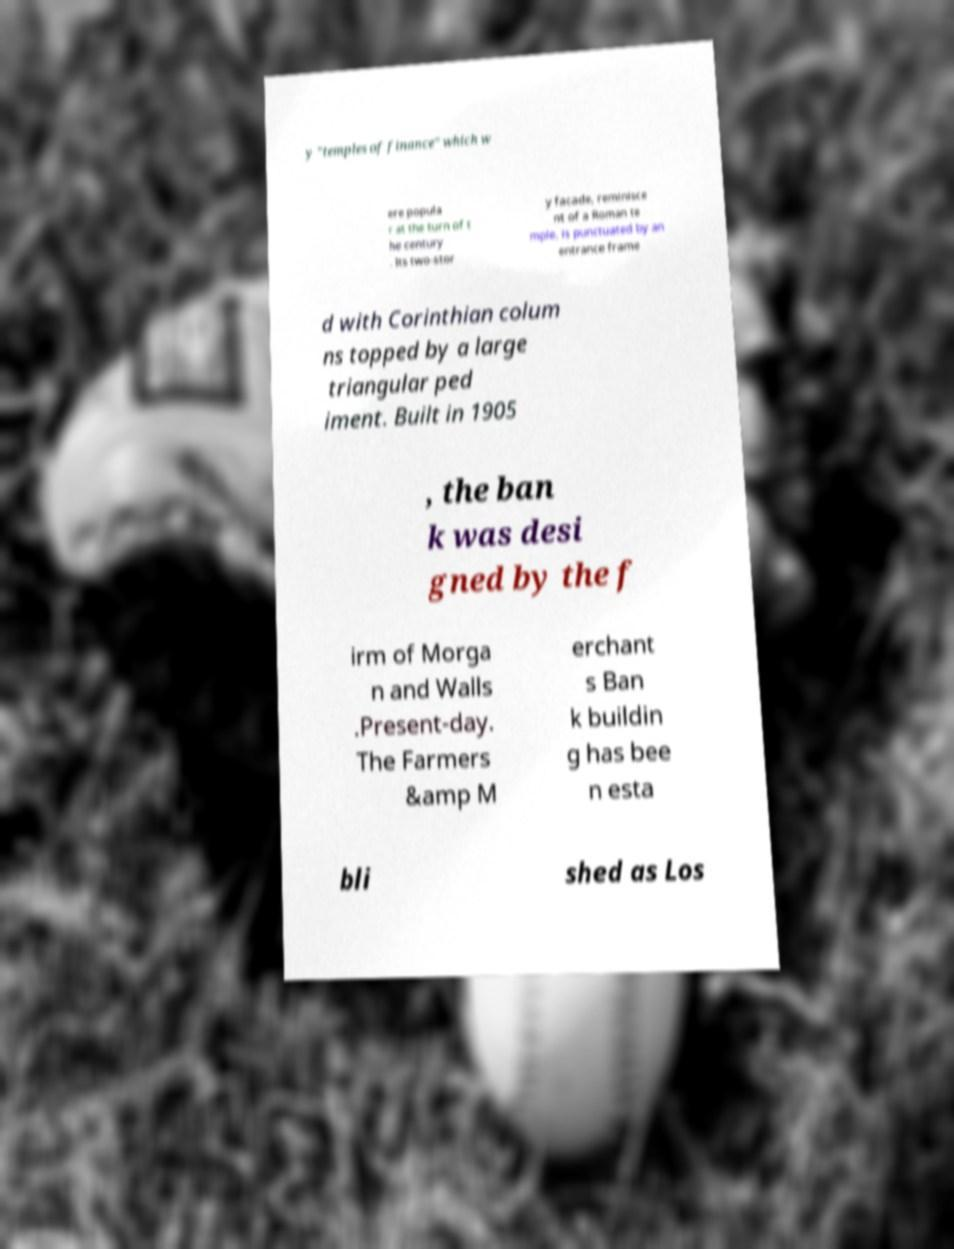Could you assist in decoding the text presented in this image and type it out clearly? y "temples of finance" which w ere popula r at the turn of t he century . Its two-stor y facade, reminisce nt of a Roman te mple, is punctuated by an entrance frame d with Corinthian colum ns topped by a large triangular ped iment. Built in 1905 , the ban k was desi gned by the f irm of Morga n and Walls .Present-day. The Farmers &amp M erchant s Ban k buildin g has bee n esta bli shed as Los 